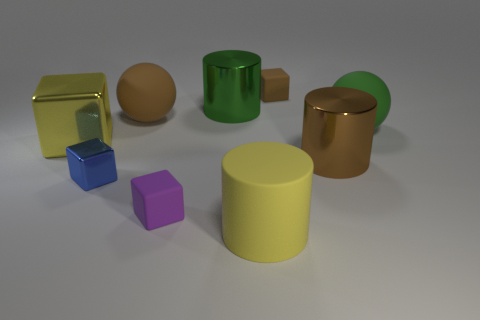What shapes are present in this image? The image includes a variety of shapes such as cubes, a sphere, cylinders, and what appears to be a cuboid. 